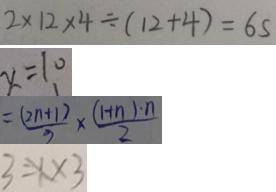Convert formula to latex. <formula><loc_0><loc_0><loc_500><loc_500>2 \times 1 2 \times 4 \div ( 1 2 + 4 ) = 6 s 
 x = 1 0 
 = \frac { ( 2 n + 1 ) } { 3 } \times \frac { ( 1 + n ) \cdot n } { 2 } 
 3 = X \times 3</formula> 